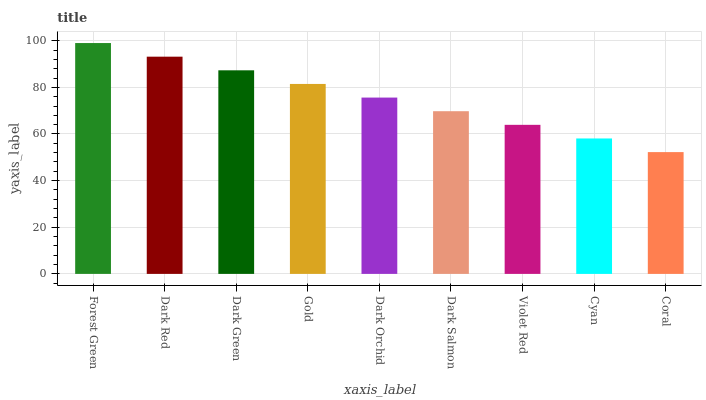Is Coral the minimum?
Answer yes or no. Yes. Is Forest Green the maximum?
Answer yes or no. Yes. Is Dark Red the minimum?
Answer yes or no. No. Is Dark Red the maximum?
Answer yes or no. No. Is Forest Green greater than Dark Red?
Answer yes or no. Yes. Is Dark Red less than Forest Green?
Answer yes or no. Yes. Is Dark Red greater than Forest Green?
Answer yes or no. No. Is Forest Green less than Dark Red?
Answer yes or no. No. Is Dark Orchid the high median?
Answer yes or no. Yes. Is Dark Orchid the low median?
Answer yes or no. Yes. Is Violet Red the high median?
Answer yes or no. No. Is Dark Red the low median?
Answer yes or no. No. 